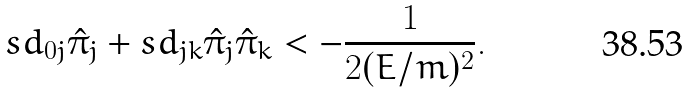Convert formula to latex. <formula><loc_0><loc_0><loc_500><loc_500>s d _ { 0 j } \hat { \pi } _ { j } + s d _ { j k } \hat { \pi } _ { j } \hat { \pi } _ { k } < - \frac { 1 } { 2 ( E / m ) ^ { 2 } } .</formula> 